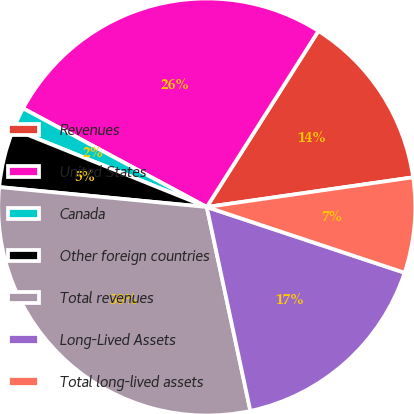Convert chart. <chart><loc_0><loc_0><loc_500><loc_500><pie_chart><fcel>Revenues<fcel>United States<fcel>Canada<fcel>Other foreign countries<fcel>Total revenues<fcel>Long-Lived Assets<fcel>Total long-lived assets<nl><fcel>13.73%<fcel>26.15%<fcel>1.75%<fcel>4.57%<fcel>29.88%<fcel>16.54%<fcel>7.38%<nl></chart> 